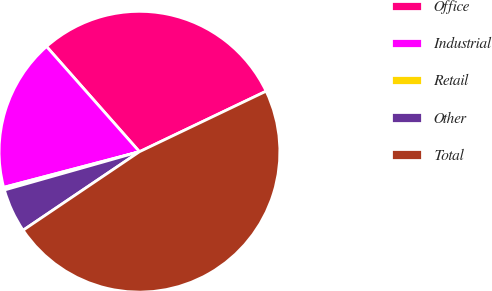<chart> <loc_0><loc_0><loc_500><loc_500><pie_chart><fcel>Office<fcel>Industrial<fcel>Retail<fcel>Other<fcel>Total<nl><fcel>29.42%<fcel>17.57%<fcel>0.31%<fcel>5.05%<fcel>47.65%<nl></chart> 